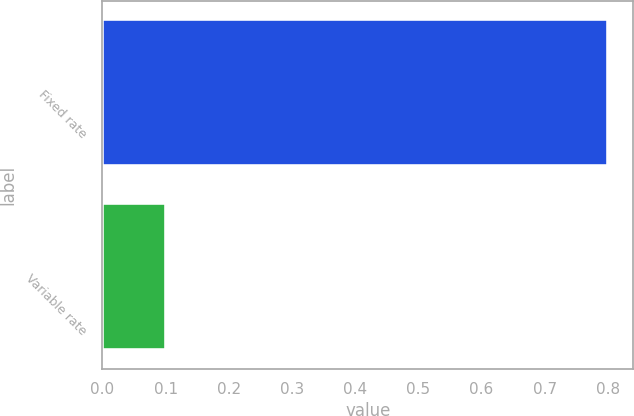Convert chart. <chart><loc_0><loc_0><loc_500><loc_500><bar_chart><fcel>Fixed rate<fcel>Variable rate<nl><fcel>0.8<fcel>0.1<nl></chart> 